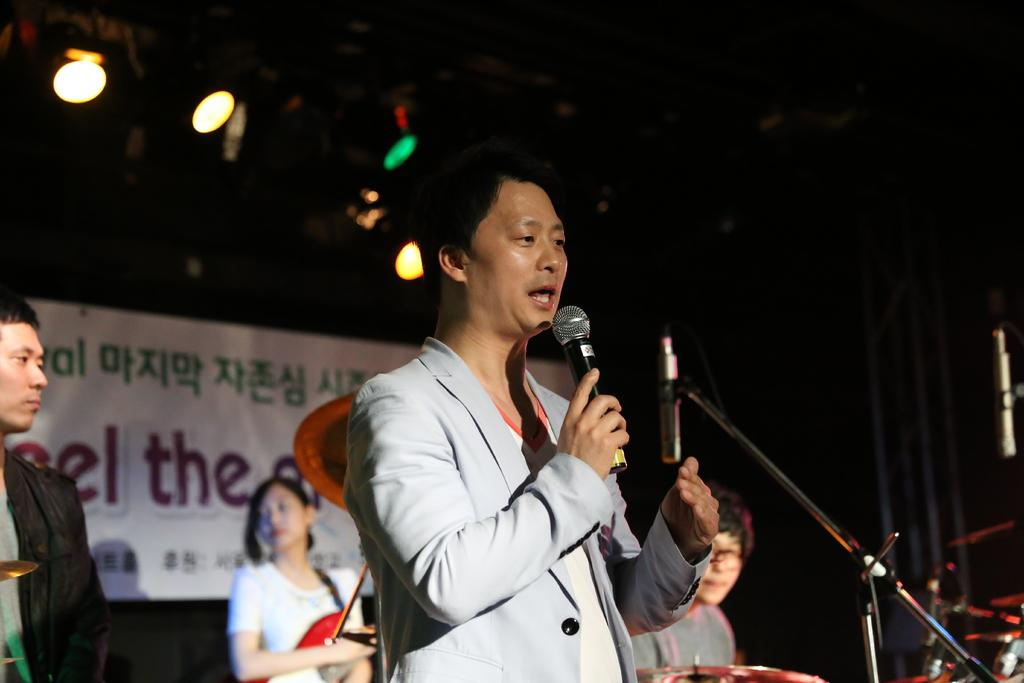What can be seen in the image that provides illumination? There is a light in the image. What is hanging in the image? There is a banner in the image. How many people are standing on stage in the image? There are three people standing on stage in the image. What is one of the people doing on stage? One of the people is talking on a microphone. How many hats are visible on the people standing on stage? There is no mention of hats in the image, so we cannot determine the number of hats present. Is there any indication of a birth occurring in the image? There is no indication of a birth occurring in the image. 